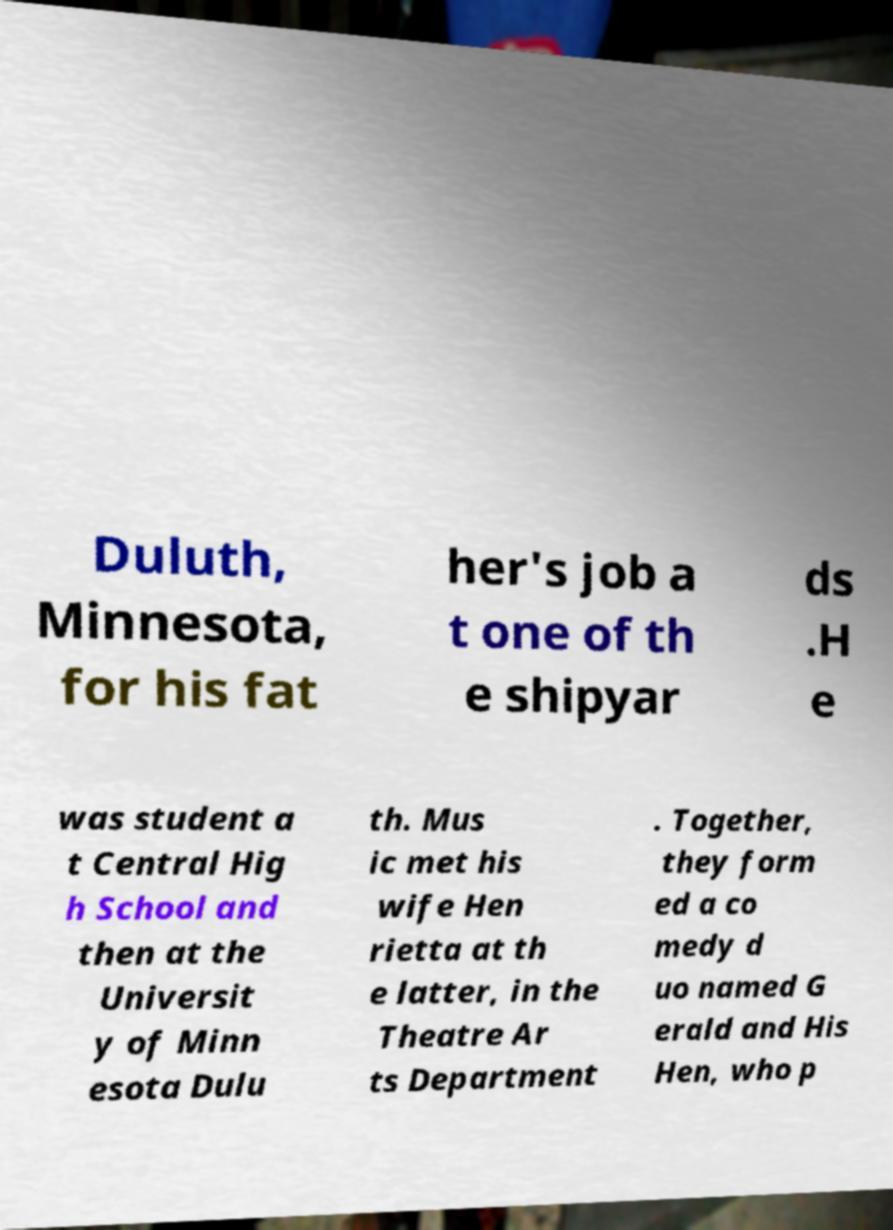What messages or text are displayed in this image? I need them in a readable, typed format. Duluth, Minnesota, for his fat her's job a t one of th e shipyar ds .H e was student a t Central Hig h School and then at the Universit y of Minn esota Dulu th. Mus ic met his wife Hen rietta at th e latter, in the Theatre Ar ts Department . Together, they form ed a co medy d uo named G erald and His Hen, who p 